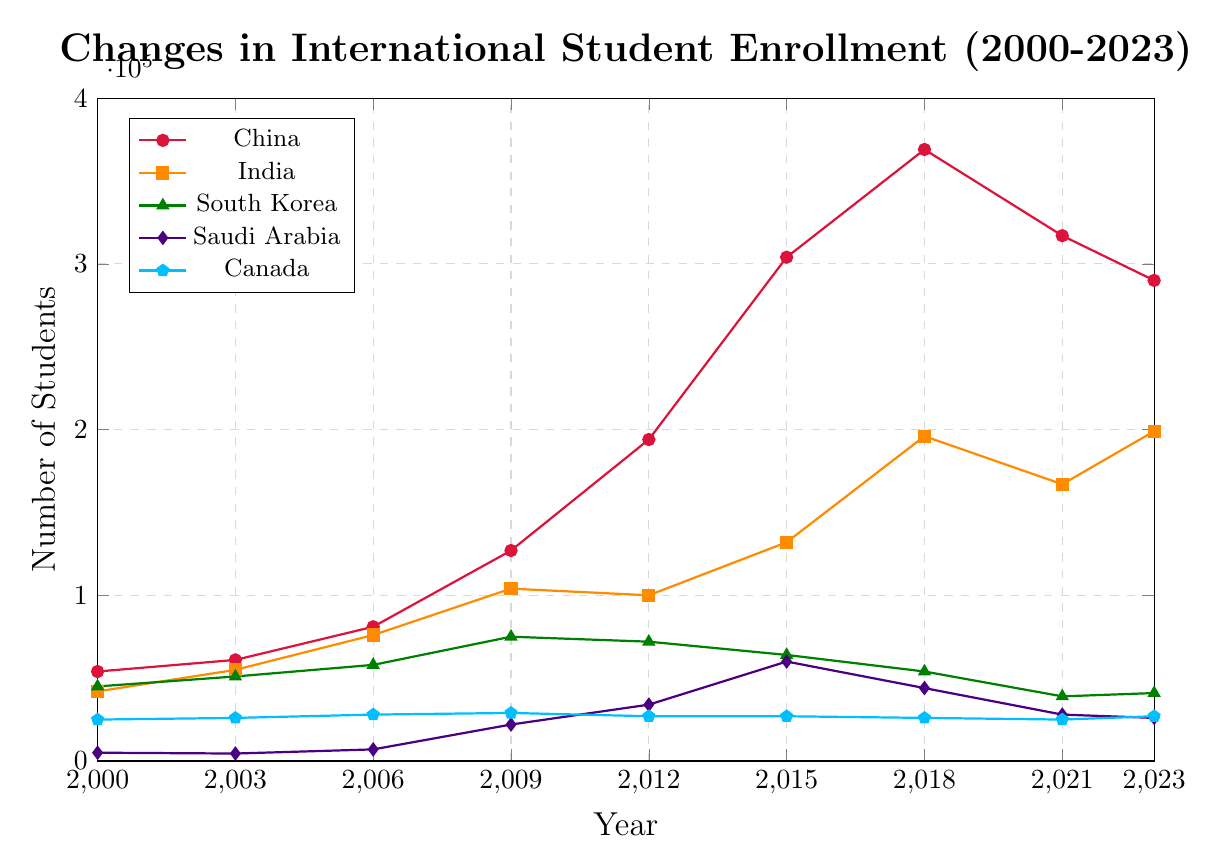Which country had the highest number of international students in 2023? The plot shows the number of international students for various countries from 2000 to 2023. For 2023, China had the highest number of students.
Answer: China How many students did India have in 2018 compared to China? From the plot, the number of students from India in 2018 was 196,000, while China had 369,000 in the same year.
Answer: India: 196,000, China: 369,000 Between which years did Saudi Arabia see its most significant increase in student enrollment? By observing the steepest slope for Saudi Arabia's line plot, the most significant increase was between 2006 and 2015, with enrollment rising drastically during this period.
Answer: 2006 to 2015 What is the average number of students from South Korea between 2000 and 2023? The plot provides the number of South Korean students for various years (2000, 2003, 2006, 2009, 2012, 2015, 2018, 2021, 2023). To get the average: (45000 + 51000 + 58000 + 75000 + 72000 + 64000 + 54000 + 39000 + 41000) / 9 = 55555.56.
Answer: 55,556 Which country showed a decreasing trend in student enrollment after 2018? By examining the plot, China shows a clear decreasing trend in student enrollment after 2018, dropping from 369,000 to 290,000 by 2023.
Answer: China In 2015, how does the number of Saudi Arabian students compare to Canadian students? The plot shows that in 2015, Saudi Arabia had 60,000 students, while Canada had 27,000 students. Saudi Arabia has 33,000 more students than Canada.
Answer: 60,000 (Saudi Arabia) vs. 27,000 (Canada) Which year had the lowest number of international students from Saudi Arabia? Observing the Saudi Arabia line, 2003 had the lowest number at 4,500 students.
Answer: 2003 By how much did the enrollment of students from India increase from 2000 to 2023? From the plot, the number of Indian students in 2000 was 42,000, and in 2023 it was 199,000. The increase is 199,000 - 42,000 = 157,000.
Answer: 157,000 